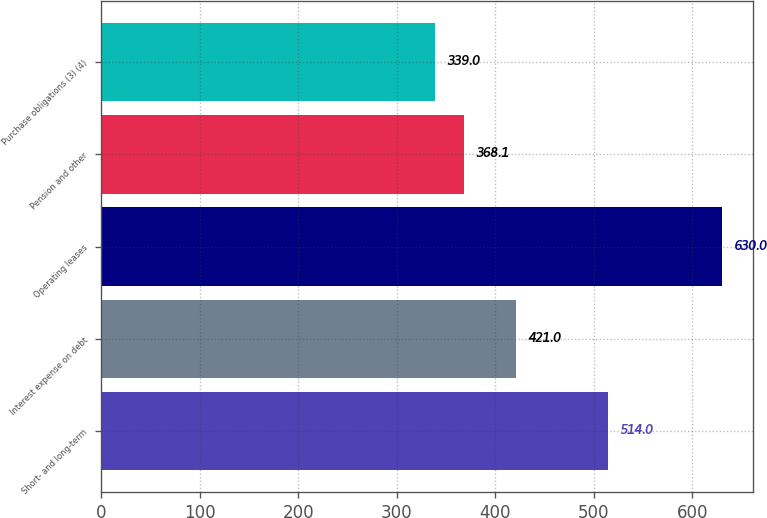Convert chart. <chart><loc_0><loc_0><loc_500><loc_500><bar_chart><fcel>Short- and long-term<fcel>Interest expense on debt<fcel>Operating leases<fcel>Pension and other<fcel>Purchase obligations (3) (4)<nl><fcel>514<fcel>421<fcel>630<fcel>368.1<fcel>339<nl></chart> 